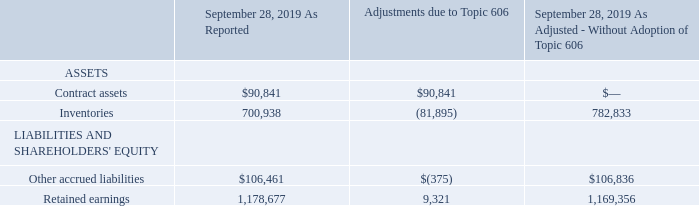15. Revenue from Contracts with Customers
Impact of Adopting Topic 606
The effects of the adoption on the Company's Consolidated Financial Statements for the fiscal year ended September 28, 2019 was as follows (in thousands):
What was the adjustments due to Topic 606 for Contract Assets?
Answer scale should be: thousand. 90,841. What was the balance before the adjustment due to Topic 606 for Retained earnings?
Answer scale should be: thousand. 1,178,677. What was the balance after the adjustment due to Topic 606 for Inventories?
Answer scale should be: thousand. 782,833. How many types of assets and liabilities had adjustments that exceeded $10,000 thousand? Contract assets##Inventories
Answer: 2. What was the difference between the balance before adjustment for Retained earnings and Other accrued liabilities?
Answer scale should be: thousand. 1,178,677-106,461
Answer: 1072216. What was the percentage change in other accrued liabilities due to adjustment from Topic 606?
Answer scale should be: percent. (106,836-106,461)/106,461
Answer: 0.35. 